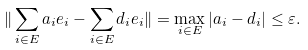Convert formula to latex. <formula><loc_0><loc_0><loc_500><loc_500>\| \sum _ { i \in E } a _ { i } e _ { i } - \sum _ { i \in E } d _ { i } e _ { i } \| = \max _ { i \in E } | a _ { i } - d _ { i } | \leq \varepsilon .</formula> 